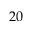<formula> <loc_0><loc_0><loc_500><loc_500>2 0</formula> 